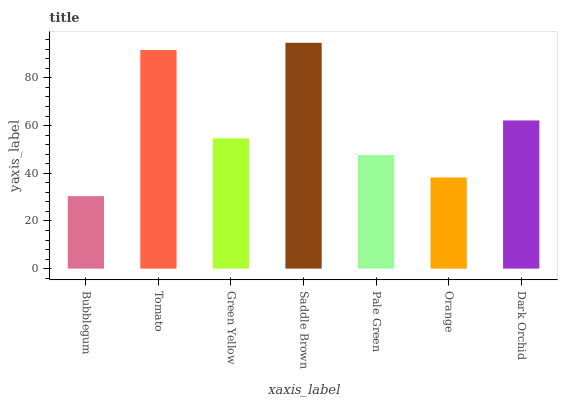Is Bubblegum the minimum?
Answer yes or no. Yes. Is Saddle Brown the maximum?
Answer yes or no. Yes. Is Tomato the minimum?
Answer yes or no. No. Is Tomato the maximum?
Answer yes or no. No. Is Tomato greater than Bubblegum?
Answer yes or no. Yes. Is Bubblegum less than Tomato?
Answer yes or no. Yes. Is Bubblegum greater than Tomato?
Answer yes or no. No. Is Tomato less than Bubblegum?
Answer yes or no. No. Is Green Yellow the high median?
Answer yes or no. Yes. Is Green Yellow the low median?
Answer yes or no. Yes. Is Pale Green the high median?
Answer yes or no. No. Is Orange the low median?
Answer yes or no. No. 